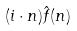<formula> <loc_0><loc_0><loc_500><loc_500>( i \cdot n ) \hat { f } ( n )</formula> 